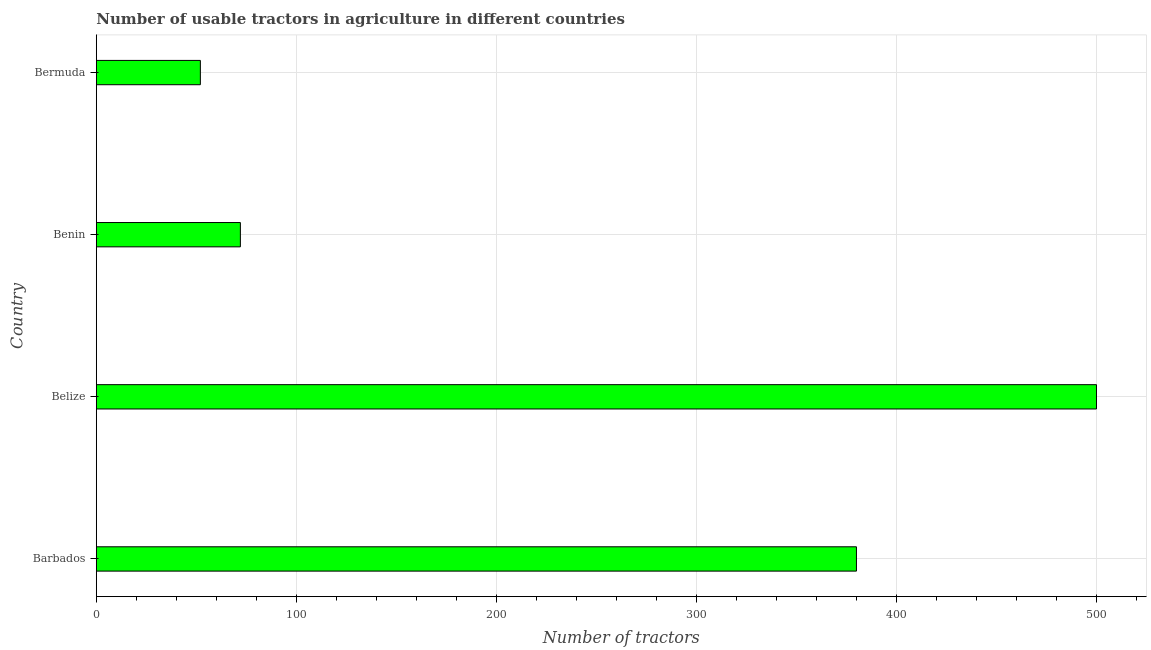Does the graph contain any zero values?
Your answer should be very brief. No. What is the title of the graph?
Provide a short and direct response. Number of usable tractors in agriculture in different countries. What is the label or title of the X-axis?
Keep it short and to the point. Number of tractors. What is the number of tractors in Barbados?
Ensure brevity in your answer.  380. Across all countries, what is the minimum number of tractors?
Offer a very short reply. 52. In which country was the number of tractors maximum?
Your response must be concise. Belize. In which country was the number of tractors minimum?
Your answer should be very brief. Bermuda. What is the sum of the number of tractors?
Provide a short and direct response. 1004. What is the difference between the number of tractors in Barbados and Benin?
Keep it short and to the point. 308. What is the average number of tractors per country?
Make the answer very short. 251. What is the median number of tractors?
Ensure brevity in your answer.  226. In how many countries, is the number of tractors greater than 40 ?
Your response must be concise. 4. What is the ratio of the number of tractors in Barbados to that in Belize?
Offer a very short reply. 0.76. What is the difference between the highest and the second highest number of tractors?
Your response must be concise. 120. Is the sum of the number of tractors in Barbados and Bermuda greater than the maximum number of tractors across all countries?
Offer a terse response. No. What is the difference between the highest and the lowest number of tractors?
Give a very brief answer. 448. How many bars are there?
Provide a short and direct response. 4. What is the difference between two consecutive major ticks on the X-axis?
Offer a terse response. 100. What is the Number of tractors of Barbados?
Offer a terse response. 380. What is the Number of tractors in Bermuda?
Your answer should be compact. 52. What is the difference between the Number of tractors in Barbados and Belize?
Your answer should be compact. -120. What is the difference between the Number of tractors in Barbados and Benin?
Your answer should be very brief. 308. What is the difference between the Number of tractors in Barbados and Bermuda?
Provide a succinct answer. 328. What is the difference between the Number of tractors in Belize and Benin?
Ensure brevity in your answer.  428. What is the difference between the Number of tractors in Belize and Bermuda?
Make the answer very short. 448. What is the difference between the Number of tractors in Benin and Bermuda?
Make the answer very short. 20. What is the ratio of the Number of tractors in Barbados to that in Belize?
Your answer should be very brief. 0.76. What is the ratio of the Number of tractors in Barbados to that in Benin?
Your response must be concise. 5.28. What is the ratio of the Number of tractors in Barbados to that in Bermuda?
Provide a succinct answer. 7.31. What is the ratio of the Number of tractors in Belize to that in Benin?
Make the answer very short. 6.94. What is the ratio of the Number of tractors in Belize to that in Bermuda?
Your response must be concise. 9.62. What is the ratio of the Number of tractors in Benin to that in Bermuda?
Make the answer very short. 1.39. 